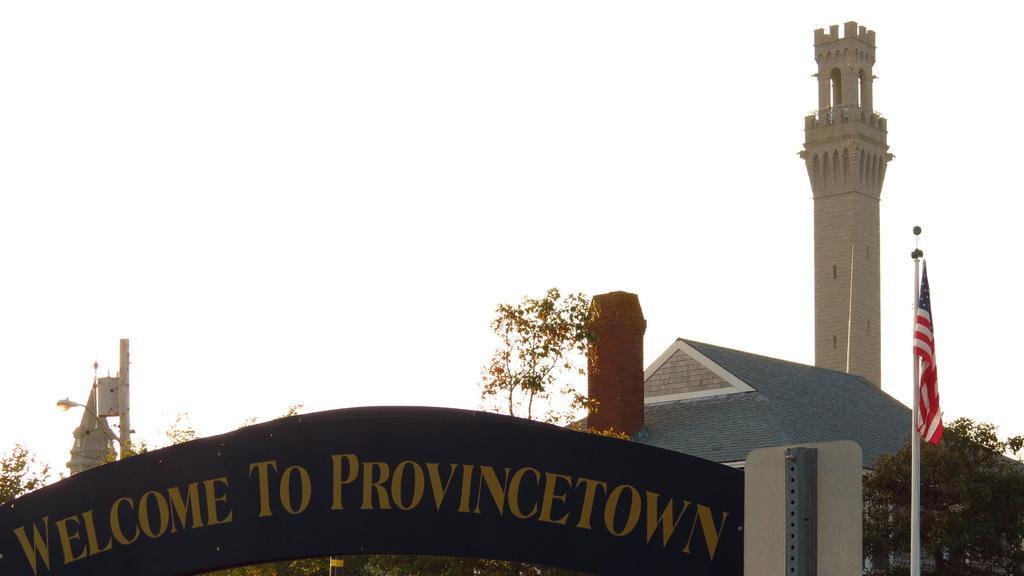Can you describe this image briefly? In this image on the right, there are trees, house, flag, pole and text board. On the left there are trees, street light, poles, steeple and sky. 